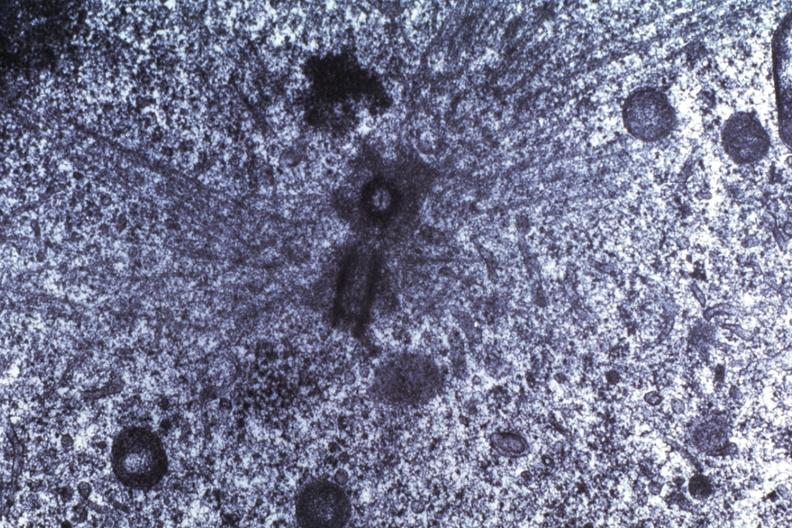what does this image show?
Answer the question using a single word or phrase. Basal body dr garcia tumors 66 